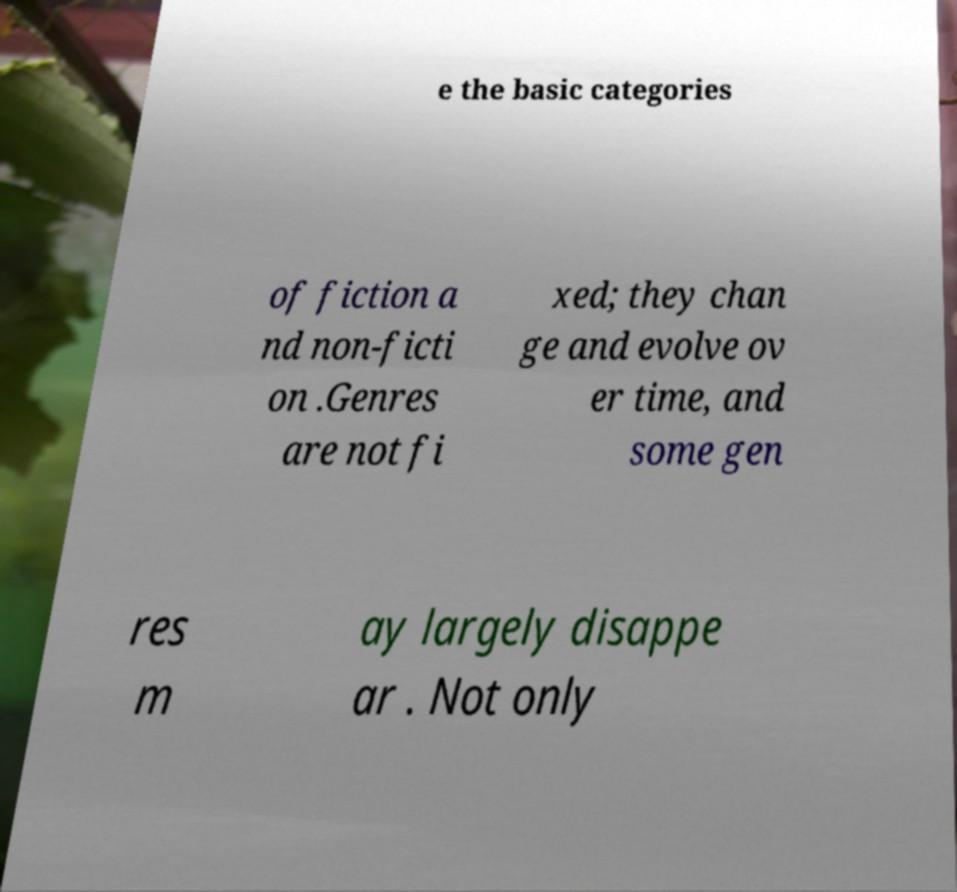Could you assist in decoding the text presented in this image and type it out clearly? e the basic categories of fiction a nd non-ficti on .Genres are not fi xed; they chan ge and evolve ov er time, and some gen res m ay largely disappe ar . Not only 